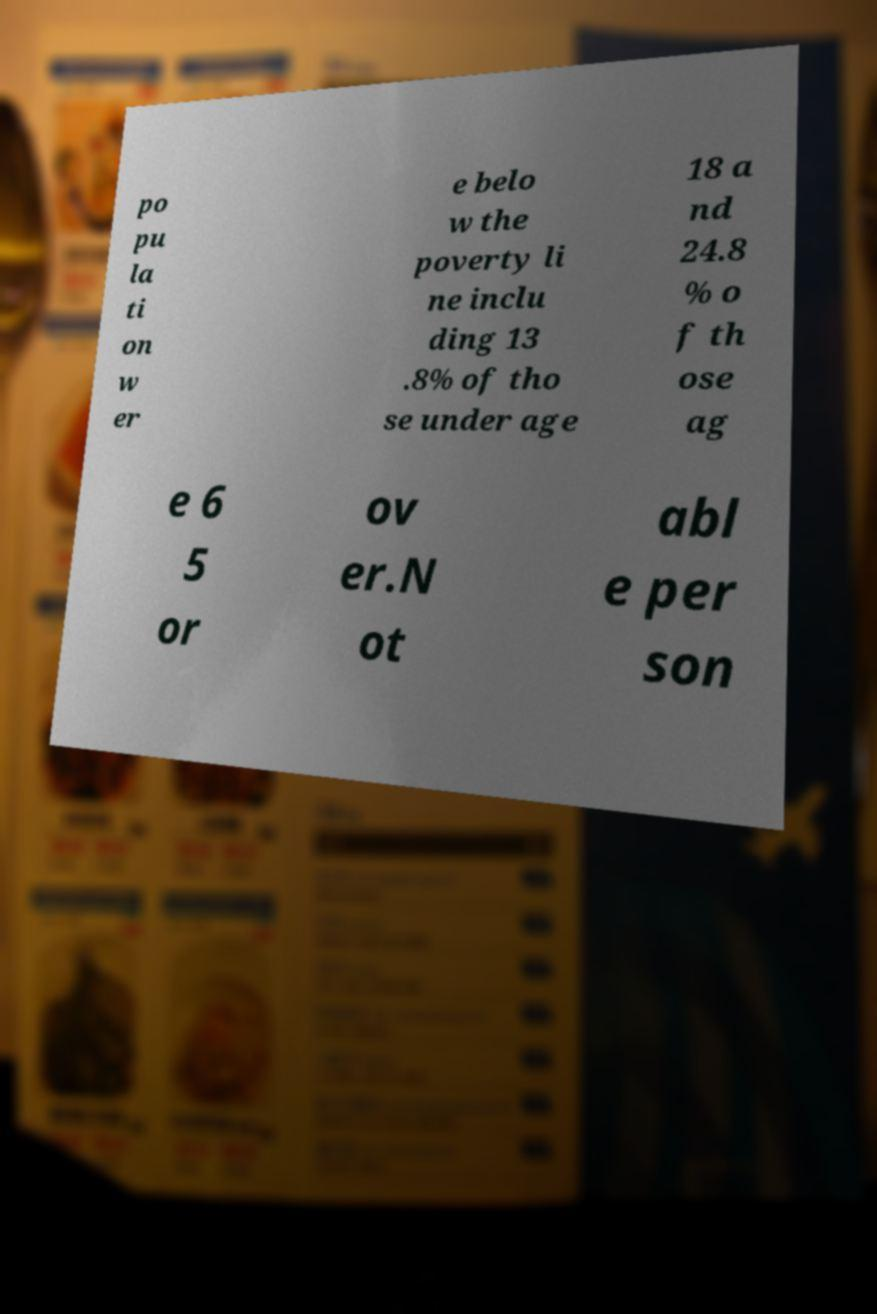I need the written content from this picture converted into text. Can you do that? po pu la ti on w er e belo w the poverty li ne inclu ding 13 .8% of tho se under age 18 a nd 24.8 % o f th ose ag e 6 5 or ov er.N ot abl e per son 